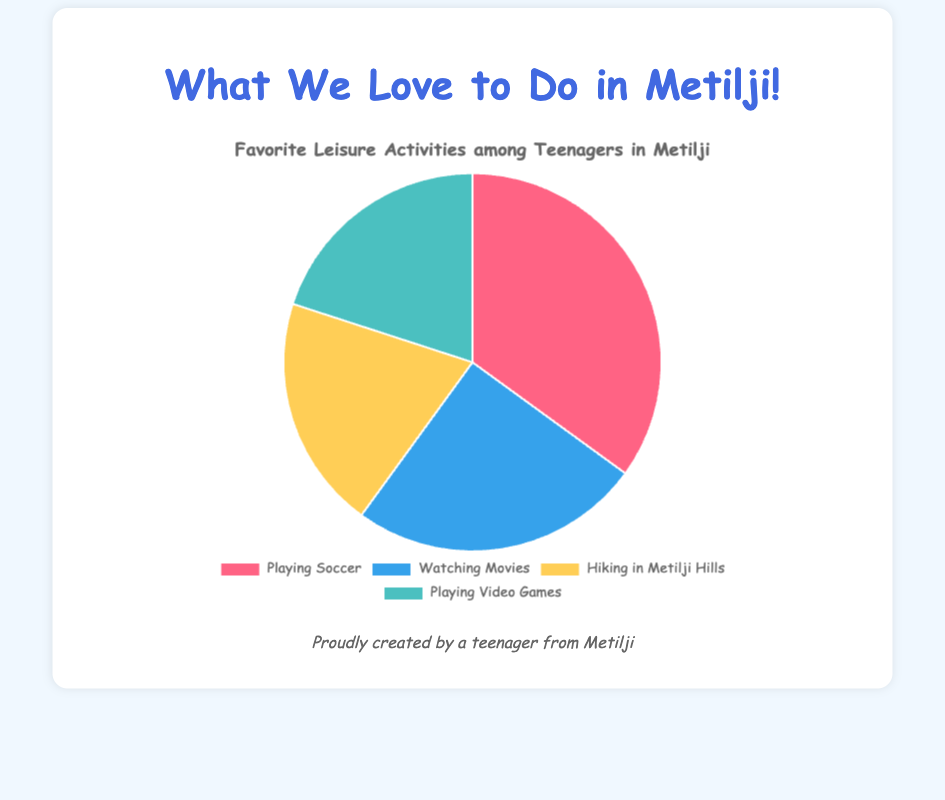Which activity is the most popular among teenagers in Metilji? The activity with the highest percentage in the pie chart is the most popular.
Answer: Playing Soccer How many activities share the same percentage of popularity? By looking at the pie chart, we can see that two activities have the same percentage of 20%.
Answer: Two activities What is the difference in popularity between Playing Soccer and Watching Movies? Playing Soccer has 35%, and Watching Movies has 25%. The difference is 35% - 25% = 10%.
Answer: 10% If you combine the percentages of Hiking in Metilji Hills and Playing Video Games, what percentage do you get? Both Hiking in Metilji Hills and Playing Video Games have 20%. Adding them together gives 20% + 20% = 40%.
Answer: 40% Which activity is represented by the color blue in the pie chart? The pie chart shows that the activity with the 25% slice, which is Watching Movies, is represented by blue.
Answer: Watching Movies Is the combined percentage of Watching Movies and Playing Video Games more than half of the total activities? Watching Movies has 25% and Playing Video Games has 20%. Combined, they have 25% + 20% = 45%, which is less than 50%.
Answer: No What percentage more popular is Playing Soccer compared to Hiking in Metilji Hills? Playing Soccer has 35%, and Hiking in Metilji Hills has 20%. The difference is 35% - 20% = 15%.
Answer: 15% What percentage of teenagers prefer activities other than Playing Soccer? Playing Soccer is preferred by 35%, so the percentage of those preferring other activities is 100% - 35% = 65%.
Answer: 65% Is the popularity of Playing Video Games equal to that of Hiking in Metilji Hills? Both Playing Video Games and Hiking in Metilji Hills have a percentage of 20% each.
Answer: Yes What is the average popularity percentage of all listed activities? The percentages are 35%, 25%, 20%, and 20%. The average is (35 + 25 + 20 + 20) / 4 = 100 / 4 = 25%.
Answer: 25% 